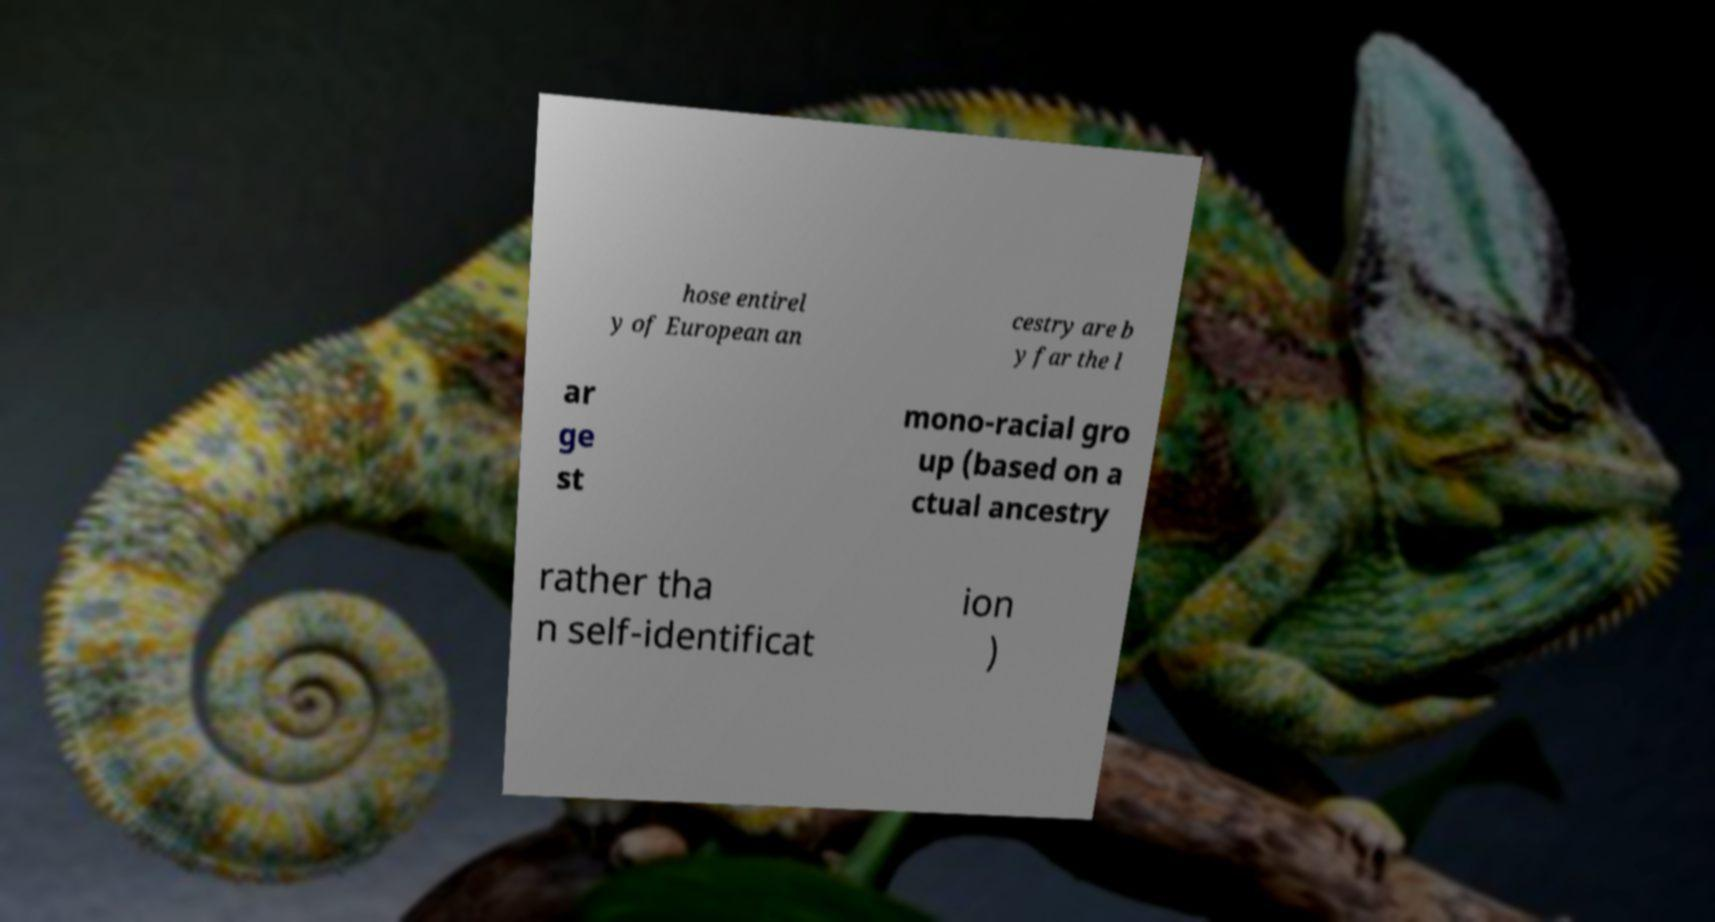Can you read and provide the text displayed in the image?This photo seems to have some interesting text. Can you extract and type it out for me? hose entirel y of European an cestry are b y far the l ar ge st mono-racial gro up (based on a ctual ancestry rather tha n self-identificat ion ) 